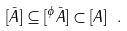<formula> <loc_0><loc_0><loc_500><loc_500>[ \bar { A } ] \subseteq [ ^ { \phi } \bar { A } ] \subset [ A ] \ .</formula> 